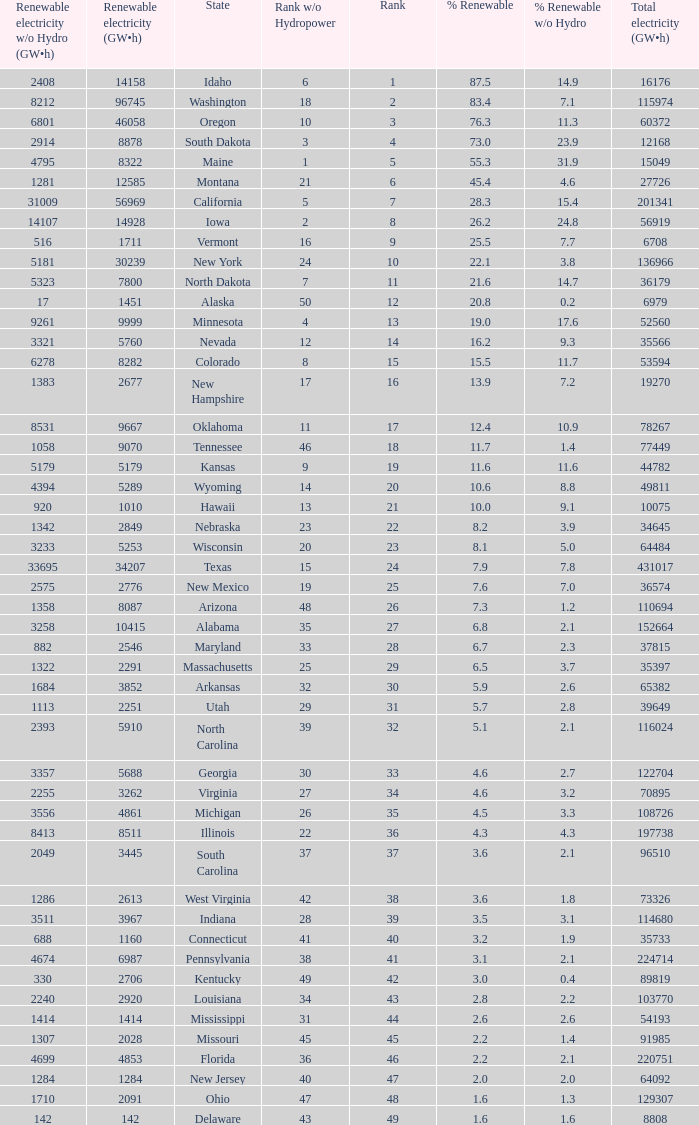Could you parse the entire table as a dict? {'header': ['Renewable electricity w/o Hydro (GW•h)', 'Renewable electricity (GW•h)', 'State', 'Rank w/o Hydropower', 'Rank', '% Renewable', '% Renewable w/o Hydro', 'Total electricity (GW•h)'], 'rows': [['2408', '14158', 'Idaho', '6', '1', '87.5', '14.9', '16176'], ['8212', '96745', 'Washington', '18', '2', '83.4', '7.1', '115974'], ['6801', '46058', 'Oregon', '10', '3', '76.3', '11.3', '60372'], ['2914', '8878', 'South Dakota', '3', '4', '73.0', '23.9', '12168'], ['4795', '8322', 'Maine', '1', '5', '55.3', '31.9', '15049'], ['1281', '12585', 'Montana', '21', '6', '45.4', '4.6', '27726'], ['31009', '56969', 'California', '5', '7', '28.3', '15.4', '201341'], ['14107', '14928', 'Iowa', '2', '8', '26.2', '24.8', '56919'], ['516', '1711', 'Vermont', '16', '9', '25.5', '7.7', '6708'], ['5181', '30239', 'New York', '24', '10', '22.1', '3.8', '136966'], ['5323', '7800', 'North Dakota', '7', '11', '21.6', '14.7', '36179'], ['17', '1451', 'Alaska', '50', '12', '20.8', '0.2', '6979'], ['9261', '9999', 'Minnesota', '4', '13', '19.0', '17.6', '52560'], ['3321', '5760', 'Nevada', '12', '14', '16.2', '9.3', '35566'], ['6278', '8282', 'Colorado', '8', '15', '15.5', '11.7', '53594'], ['1383', '2677', 'New Hampshire', '17', '16', '13.9', '7.2', '19270'], ['8531', '9667', 'Oklahoma', '11', '17', '12.4', '10.9', '78267'], ['1058', '9070', 'Tennessee', '46', '18', '11.7', '1.4', '77449'], ['5179', '5179', 'Kansas', '9', '19', '11.6', '11.6', '44782'], ['4394', '5289', 'Wyoming', '14', '20', '10.6', '8.8', '49811'], ['920', '1010', 'Hawaii', '13', '21', '10.0', '9.1', '10075'], ['1342', '2849', 'Nebraska', '23', '22', '8.2', '3.9', '34645'], ['3233', '5253', 'Wisconsin', '20', '23', '8.1', '5.0', '64484'], ['33695', '34207', 'Texas', '15', '24', '7.9', '7.8', '431017'], ['2575', '2776', 'New Mexico', '19', '25', '7.6', '7.0', '36574'], ['1358', '8087', 'Arizona', '48', '26', '7.3', '1.2', '110694'], ['3258', '10415', 'Alabama', '35', '27', '6.8', '2.1', '152664'], ['882', '2546', 'Maryland', '33', '28', '6.7', '2.3', '37815'], ['1322', '2291', 'Massachusetts', '25', '29', '6.5', '3.7', '35397'], ['1684', '3852', 'Arkansas', '32', '30', '5.9', '2.6', '65382'], ['1113', '2251', 'Utah', '29', '31', '5.7', '2.8', '39649'], ['2393', '5910', 'North Carolina', '39', '32', '5.1', '2.1', '116024'], ['3357', '5688', 'Georgia', '30', '33', '4.6', '2.7', '122704'], ['2255', '3262', 'Virginia', '27', '34', '4.6', '3.2', '70895'], ['3556', '4861', 'Michigan', '26', '35', '4.5', '3.3', '108726'], ['8413', '8511', 'Illinois', '22', '36', '4.3', '4.3', '197738'], ['2049', '3445', 'South Carolina', '37', '37', '3.6', '2.1', '96510'], ['1286', '2613', 'West Virginia', '42', '38', '3.6', '1.8', '73326'], ['3511', '3967', 'Indiana', '28', '39', '3.5', '3.1', '114680'], ['688', '1160', 'Connecticut', '41', '40', '3.2', '1.9', '35733'], ['4674', '6987', 'Pennsylvania', '38', '41', '3.1', '2.1', '224714'], ['330', '2706', 'Kentucky', '49', '42', '3.0', '0.4', '89819'], ['2240', '2920', 'Louisiana', '34', '43', '2.8', '2.2', '103770'], ['1414', '1414', 'Mississippi', '31', '44', '2.6', '2.6', '54193'], ['1307', '2028', 'Missouri', '45', '45', '2.2', '1.4', '91985'], ['4699', '4853', 'Florida', '36', '46', '2.2', '2.1', '220751'], ['1284', '1284', 'New Jersey', '40', '47', '2.0', '2.0', '64092'], ['1710', '2091', 'Ohio', '47', '48', '1.6', '1.3', '129307'], ['142', '142', 'Delaware', '43', '49', '1.6', '1.6', '8808']]} Which state has 5179 (gw×h) of renewable energy without hydrogen power?wha Kansas. 